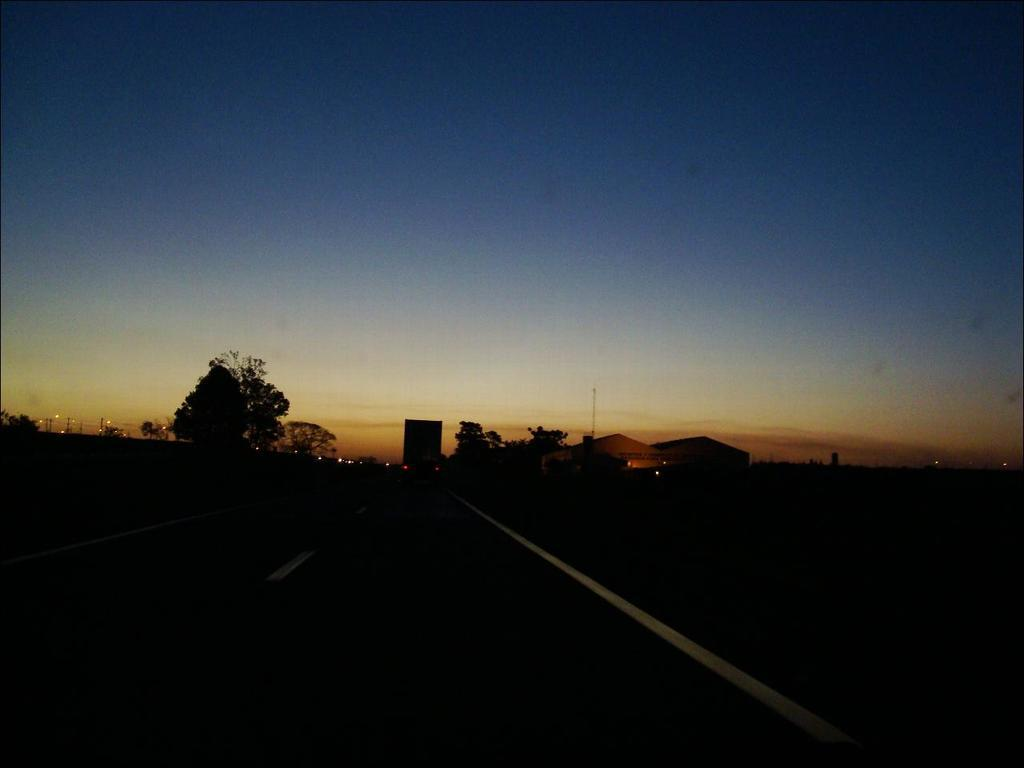What type of man-made structure can be seen in the image? There are buildings in the image. What natural elements are present in the image? There are trees in the image. What is the condition of the sky in the image? The sky is clear in the image. What type of pathway is visible in the image? There is a road in the image. Can you tell me how many quince trees are present in the image? There is no mention of quince trees in the image; the image only features trees in general. What type of expert is shown giving a lecture in the image? There is no expert or lecture present in the image. 